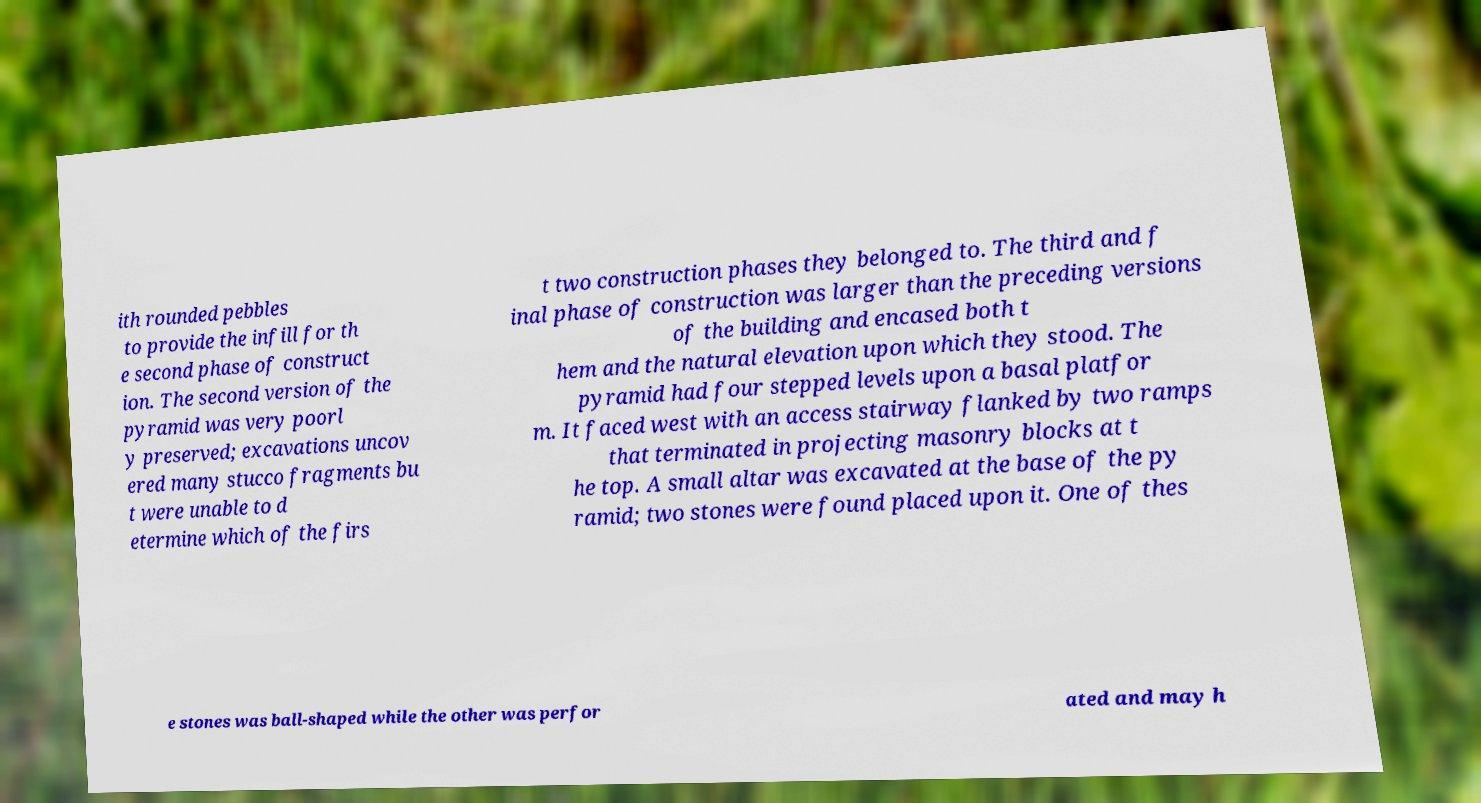I need the written content from this picture converted into text. Can you do that? ith rounded pebbles to provide the infill for th e second phase of construct ion. The second version of the pyramid was very poorl y preserved; excavations uncov ered many stucco fragments bu t were unable to d etermine which of the firs t two construction phases they belonged to. The third and f inal phase of construction was larger than the preceding versions of the building and encased both t hem and the natural elevation upon which they stood. The pyramid had four stepped levels upon a basal platfor m. It faced west with an access stairway flanked by two ramps that terminated in projecting masonry blocks at t he top. A small altar was excavated at the base of the py ramid; two stones were found placed upon it. One of thes e stones was ball-shaped while the other was perfor ated and may h 